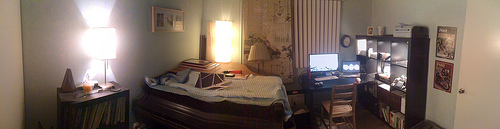Tell me more about the artwork on the wall. The artwork on the wall appears to be a framed poster or print, featuring what seems like an illustration or a photograph with a blend of darker and vibrant colors, adding a touch of personality to the room. 